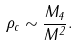<formula> <loc_0><loc_0><loc_500><loc_500>\rho _ { c } \sim \frac { M _ { 4 } } { M ^ { 2 } } .</formula> 